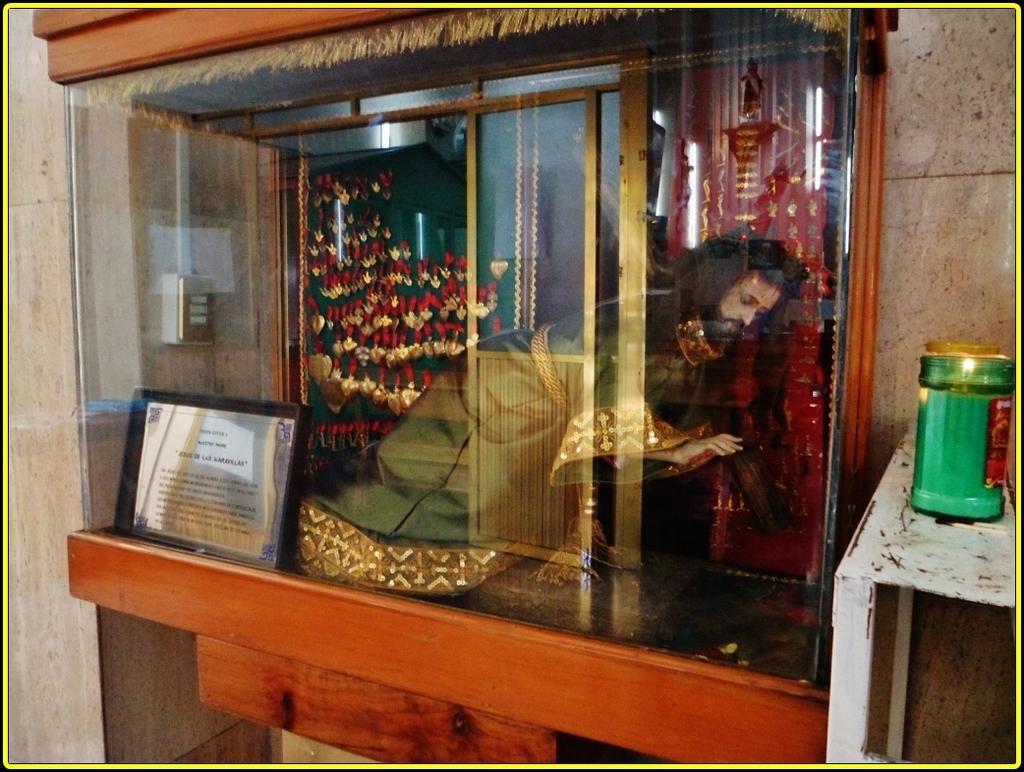In one or two sentences, can you explain what this image depicts? In this image we can see a statue and a board with text inside the box and in the background there is a curtain and on the left side there is an object to the wall and on the right side there is a table and an object looks like a candle on the table. 